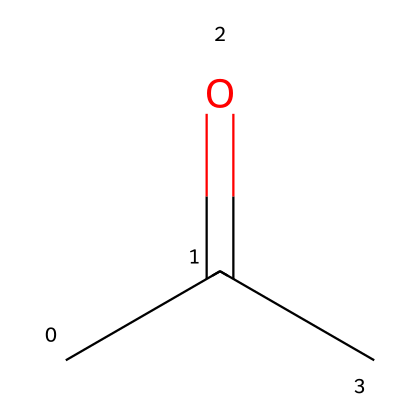What is the molecular formula of this compound? The SMILES notation "CC(=O)C" indicates that the compound contains three carbon atoms (C), with one oxygen atom (O) connected to a carbon atom through a double bond. This leads to the molecular formula C3H6O.
Answer: C3H6O How many hydrogen atoms are present in acetone? From the molecular formula C3H6O derived from the SMILES representation, it is clear there are six hydrogen atoms (H) associated with the three carbon atoms.
Answer: 6 What functional group is present in acetone? The "C(=O)" part of the SMILES structure indicates a carbonyl group, which is characteristic of ketones. Since acetone is a ketone, this is its functional group.
Answer: ketone Is acetone polar or nonpolar? Acetone contains a polar carbonyl group (C=O) that can create partial positive and negative charges, making the molecule overall polar.
Answer: polar What is the main purpose of acetone in nail polish removers? Acetone is a solvent that effectively dissolves other substances, which allows it to remove nail polish by breaking down the ingredients in the polish.
Answer: solvent How many total bonds are present in acetone? Analyzing the structure from the SMILES, there are single bonds between two carbon atoms, a double bond with oxygen, and additional bonds to hydrogen, totaling eight bonds (three C-C, one C=O, and four C-H).
Answer: 8 Why is acetone considered an effective solvent? Acetone's ability to dissolve a wide range of substances, due to its polar nature and low molecular weight, contributes to its classification as an effective solvent in various applications including nail polish removers.
Answer: effective solvent 